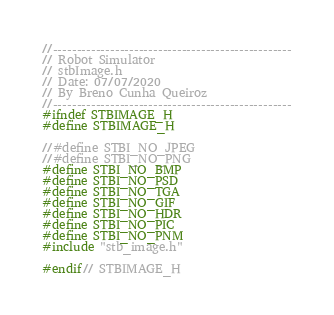Convert code to text. <code><loc_0><loc_0><loc_500><loc_500><_C_>//--------------------------------------------------
// Robot Simulator
// stbImage.h
// Date: 07/07/2020
// By Breno Cunha Queiroz
//--------------------------------------------------
#ifndef STBIMAGE_H
#define STBIMAGE_H

//#define STBI_NO_JPEG
//#define STBI_NO_PNG
#define STBI_NO_BMP
#define STBI_NO_PSD
#define STBI_NO_TGA
#define STBI_NO_GIF
#define STBI_NO_HDR
#define STBI_NO_PIC
#define STBI_NO_PNM
#include "stb_image.h"

#endif// STBIMAGE_H
</code> 